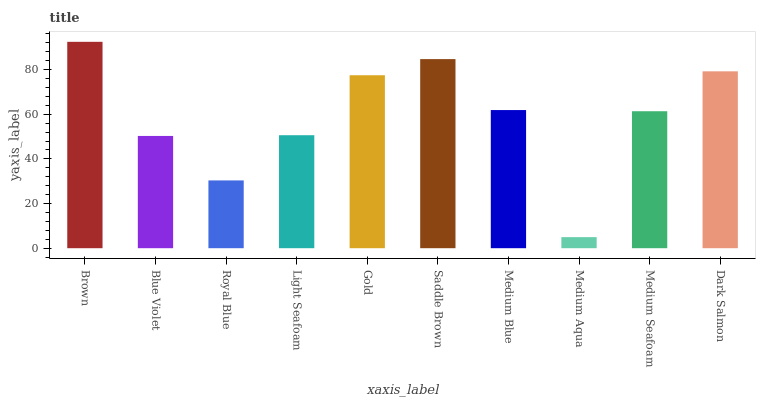Is Blue Violet the minimum?
Answer yes or no. No. Is Blue Violet the maximum?
Answer yes or no. No. Is Brown greater than Blue Violet?
Answer yes or no. Yes. Is Blue Violet less than Brown?
Answer yes or no. Yes. Is Blue Violet greater than Brown?
Answer yes or no. No. Is Brown less than Blue Violet?
Answer yes or no. No. Is Medium Blue the high median?
Answer yes or no. Yes. Is Medium Seafoam the low median?
Answer yes or no. Yes. Is Dark Salmon the high median?
Answer yes or no. No. Is Dark Salmon the low median?
Answer yes or no. No. 